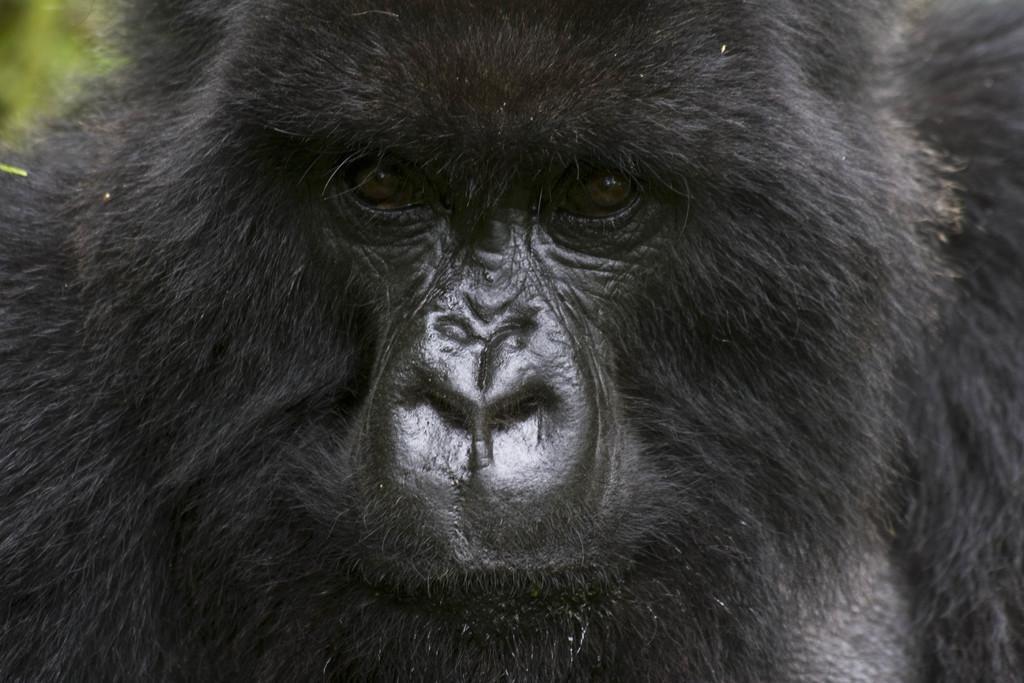How would you summarize this image in a sentence or two? In this image, we can see a chimpanzee. 